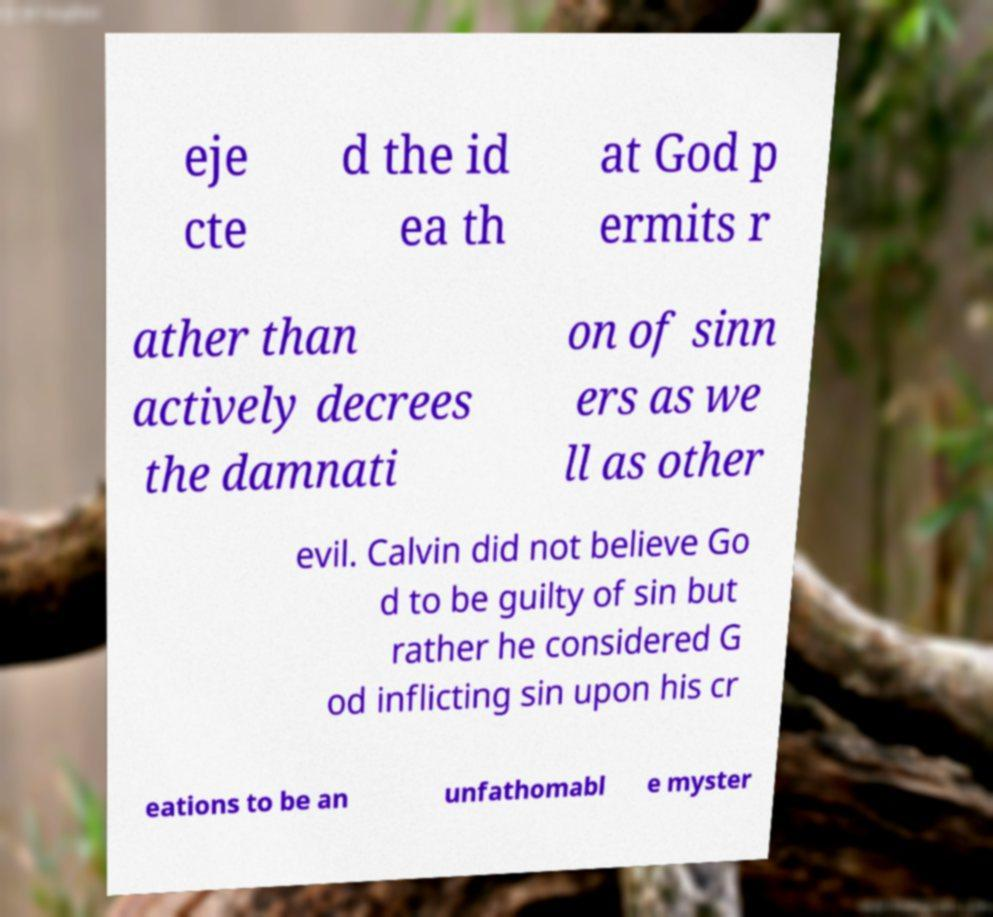I need the written content from this picture converted into text. Can you do that? eje cte d the id ea th at God p ermits r ather than actively decrees the damnati on of sinn ers as we ll as other evil. Calvin did not believe Go d to be guilty of sin but rather he considered G od inflicting sin upon his cr eations to be an unfathomabl e myster 